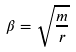Convert formula to latex. <formula><loc_0><loc_0><loc_500><loc_500>\beta = \sqrt { \frac { m } { r } }</formula> 